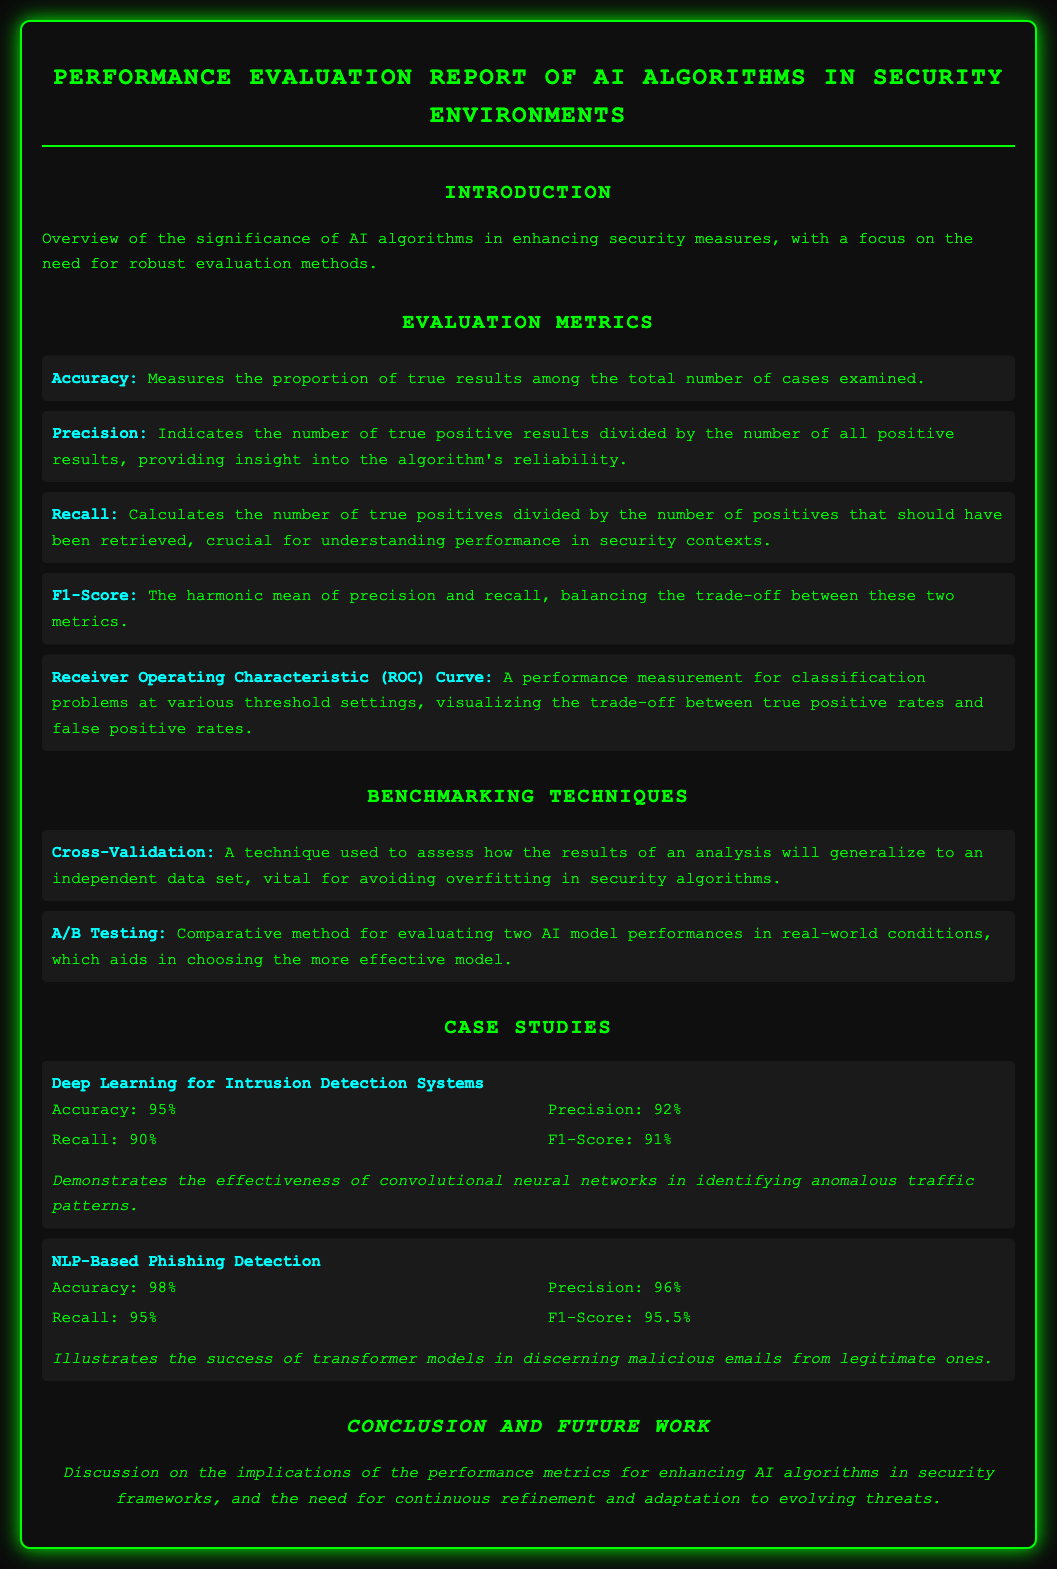What is the title of the document? The title is stated prominently at the top of the document, indicating the focus on AI algorithms in security environments.
Answer: Performance Evaluation Report of AI Algorithms in Security Environments What is the accuracy of the NLP-Based Phishing Detection case study? The accuracy is provided as a specific metric for this case study, highlighting its performance.
Answer: 98% What is the F1-Score for the Deep Learning for Intrusion Detection Systems case study? The F1-Score is part of the results listed for this specific case study.
Answer: 91% What technique is used to avoid overfitting in security algorithms? The document lists this specific benchmarking technique as crucial for generalizing results.
Answer: Cross-Validation Which metric indicates the algorithm's reliability? This metric is specifically defined in the evaluation metrics section of the document.
Answer: Precision What is the recall value for NLP-Based Phishing Detection? The recall is one of the performance metrics presented for this case study.
Answer: 95% What are the two benchmarking techniques mentioned in the document? The document lists both techniques in the benchmarking techniques section for evaluating AI performance.
Answer: Cross-Validation, A/B Testing What is the primary focus of the introduction section? The overview includes insights on the significance of AI algorithms in security measures.
Answer: Robust evaluation methods What is the receiver operating characteristic curve used for? This metric is described in the document as a performance measurement for certain types of problems.
Answer: Visualizing the trade-off between true positive rates and false positive rates 